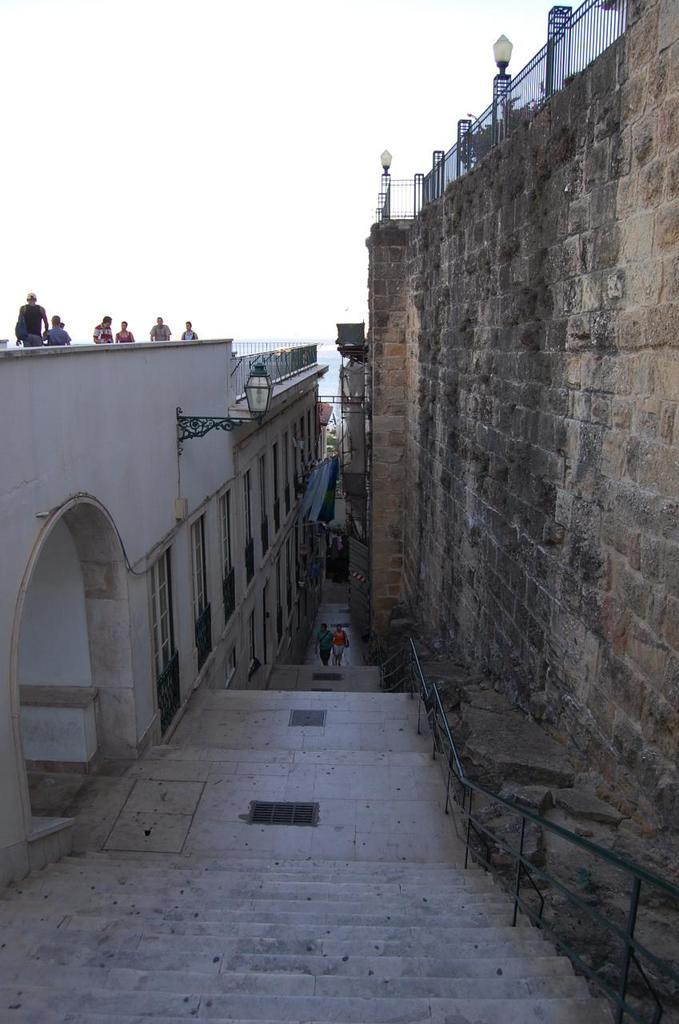What type of architectural feature is present in the image? There are steps in the image. What is located to the right of the steps? There is a wall to the right of the steps. What is located to the left of the steps? There is a building to the left of the steps. What can be seen on the building? There are persons on the building. What is visible at the top of the image? The sky is visible at the top of the image. What type of books are being used to help the persons on the building? There are no books present in the image, and the persons on the building are not using any books to help them. 